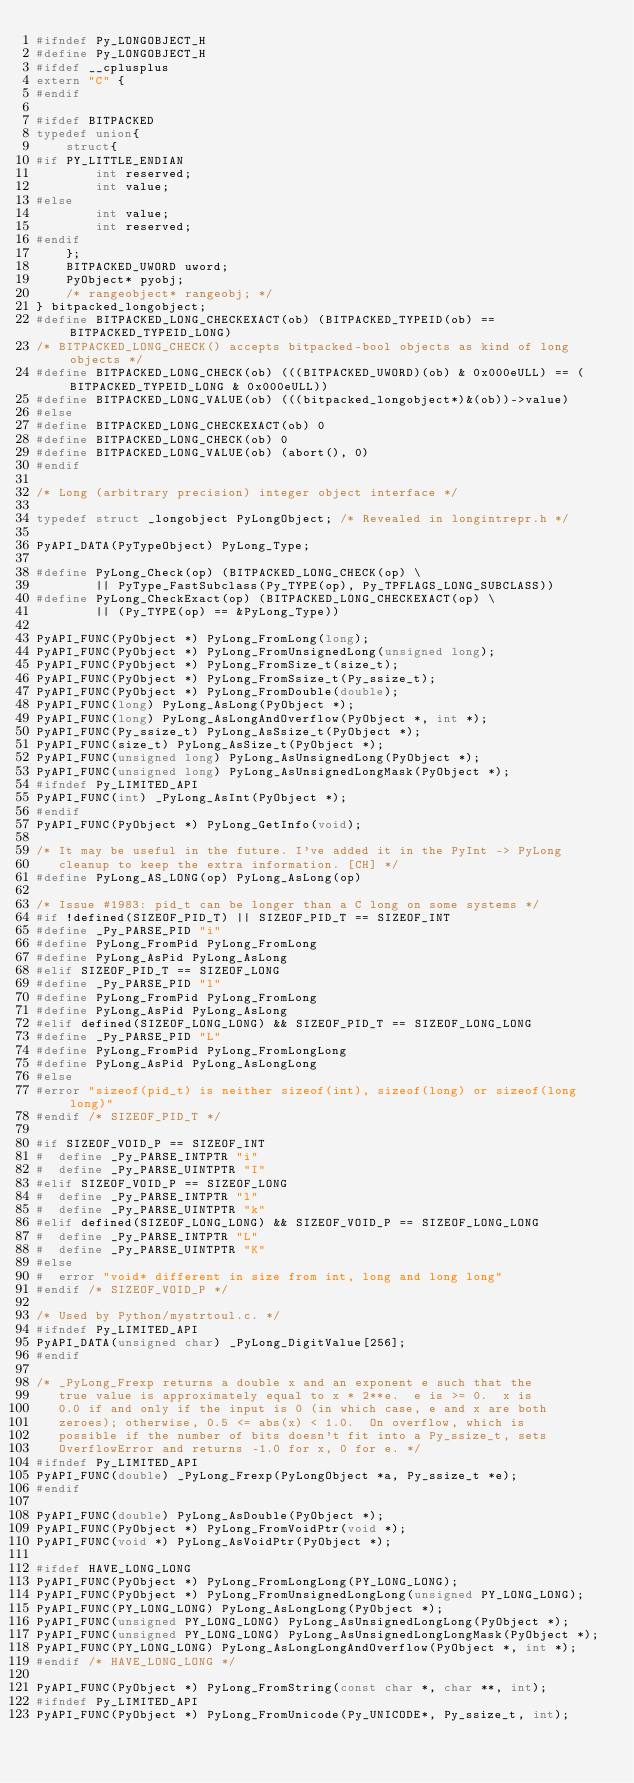<code> <loc_0><loc_0><loc_500><loc_500><_C_>#ifndef Py_LONGOBJECT_H
#define Py_LONGOBJECT_H
#ifdef __cplusplus
extern "C" {
#endif

#ifdef BITPACKED
typedef union{
    struct{
#if PY_LITTLE_ENDIAN
        int reserved;
        int value;
#else
        int value;
        int reserved;
#endif
    };
    BITPACKED_UWORD uword;
    PyObject* pyobj;
    /* rangeobject* rangeobj; */
} bitpacked_longobject;
#define BITPACKED_LONG_CHECKEXACT(ob) (BITPACKED_TYPEID(ob) == BITPACKED_TYPEID_LONG)
/* BITPACKED_LONG_CHECK() accepts bitpacked-bool objects as kind of long objects */
#define BITPACKED_LONG_CHECK(ob) (((BITPACKED_UWORD)(ob) & 0x000eULL) == (BITPACKED_TYPEID_LONG & 0x000eULL))
#define BITPACKED_LONG_VALUE(ob) (((bitpacked_longobject*)&(ob))->value)
#else
#define BITPACKED_LONG_CHECKEXACT(ob) 0
#define BITPACKED_LONG_CHECK(ob) 0
#define BITPACKED_LONG_VALUE(ob) (abort(), 0)
#endif

/* Long (arbitrary precision) integer object interface */

typedef struct _longobject PyLongObject; /* Revealed in longintrepr.h */

PyAPI_DATA(PyTypeObject) PyLong_Type;

#define PyLong_Check(op) (BITPACKED_LONG_CHECK(op) \
        || PyType_FastSubclass(Py_TYPE(op), Py_TPFLAGS_LONG_SUBCLASS))
#define PyLong_CheckExact(op) (BITPACKED_LONG_CHECKEXACT(op) \
        || (Py_TYPE(op) == &PyLong_Type))

PyAPI_FUNC(PyObject *) PyLong_FromLong(long);
PyAPI_FUNC(PyObject *) PyLong_FromUnsignedLong(unsigned long);
PyAPI_FUNC(PyObject *) PyLong_FromSize_t(size_t);
PyAPI_FUNC(PyObject *) PyLong_FromSsize_t(Py_ssize_t);
PyAPI_FUNC(PyObject *) PyLong_FromDouble(double);
PyAPI_FUNC(long) PyLong_AsLong(PyObject *);
PyAPI_FUNC(long) PyLong_AsLongAndOverflow(PyObject *, int *);
PyAPI_FUNC(Py_ssize_t) PyLong_AsSsize_t(PyObject *);
PyAPI_FUNC(size_t) PyLong_AsSize_t(PyObject *);
PyAPI_FUNC(unsigned long) PyLong_AsUnsignedLong(PyObject *);
PyAPI_FUNC(unsigned long) PyLong_AsUnsignedLongMask(PyObject *);
#ifndef Py_LIMITED_API
PyAPI_FUNC(int) _PyLong_AsInt(PyObject *);
#endif
PyAPI_FUNC(PyObject *) PyLong_GetInfo(void);

/* It may be useful in the future. I've added it in the PyInt -> PyLong
   cleanup to keep the extra information. [CH] */
#define PyLong_AS_LONG(op) PyLong_AsLong(op)

/* Issue #1983: pid_t can be longer than a C long on some systems */
#if !defined(SIZEOF_PID_T) || SIZEOF_PID_T == SIZEOF_INT
#define _Py_PARSE_PID "i"
#define PyLong_FromPid PyLong_FromLong
#define PyLong_AsPid PyLong_AsLong
#elif SIZEOF_PID_T == SIZEOF_LONG
#define _Py_PARSE_PID "l"
#define PyLong_FromPid PyLong_FromLong
#define PyLong_AsPid PyLong_AsLong
#elif defined(SIZEOF_LONG_LONG) && SIZEOF_PID_T == SIZEOF_LONG_LONG
#define _Py_PARSE_PID "L"
#define PyLong_FromPid PyLong_FromLongLong
#define PyLong_AsPid PyLong_AsLongLong
#else
#error "sizeof(pid_t) is neither sizeof(int), sizeof(long) or sizeof(long long)"
#endif /* SIZEOF_PID_T */

#if SIZEOF_VOID_P == SIZEOF_INT
#  define _Py_PARSE_INTPTR "i"
#  define _Py_PARSE_UINTPTR "I"
#elif SIZEOF_VOID_P == SIZEOF_LONG
#  define _Py_PARSE_INTPTR "l"
#  define _Py_PARSE_UINTPTR "k"
#elif defined(SIZEOF_LONG_LONG) && SIZEOF_VOID_P == SIZEOF_LONG_LONG
#  define _Py_PARSE_INTPTR "L"
#  define _Py_PARSE_UINTPTR "K"
#else
#  error "void* different in size from int, long and long long"
#endif /* SIZEOF_VOID_P */

/* Used by Python/mystrtoul.c. */
#ifndef Py_LIMITED_API
PyAPI_DATA(unsigned char) _PyLong_DigitValue[256];
#endif

/* _PyLong_Frexp returns a double x and an exponent e such that the
   true value is approximately equal to x * 2**e.  e is >= 0.  x is
   0.0 if and only if the input is 0 (in which case, e and x are both
   zeroes); otherwise, 0.5 <= abs(x) < 1.0.  On overflow, which is
   possible if the number of bits doesn't fit into a Py_ssize_t, sets
   OverflowError and returns -1.0 for x, 0 for e. */
#ifndef Py_LIMITED_API
PyAPI_FUNC(double) _PyLong_Frexp(PyLongObject *a, Py_ssize_t *e);
#endif

PyAPI_FUNC(double) PyLong_AsDouble(PyObject *);
PyAPI_FUNC(PyObject *) PyLong_FromVoidPtr(void *);
PyAPI_FUNC(void *) PyLong_AsVoidPtr(PyObject *);

#ifdef HAVE_LONG_LONG
PyAPI_FUNC(PyObject *) PyLong_FromLongLong(PY_LONG_LONG);
PyAPI_FUNC(PyObject *) PyLong_FromUnsignedLongLong(unsigned PY_LONG_LONG);
PyAPI_FUNC(PY_LONG_LONG) PyLong_AsLongLong(PyObject *);
PyAPI_FUNC(unsigned PY_LONG_LONG) PyLong_AsUnsignedLongLong(PyObject *);
PyAPI_FUNC(unsigned PY_LONG_LONG) PyLong_AsUnsignedLongLongMask(PyObject *);
PyAPI_FUNC(PY_LONG_LONG) PyLong_AsLongLongAndOverflow(PyObject *, int *);
#endif /* HAVE_LONG_LONG */

PyAPI_FUNC(PyObject *) PyLong_FromString(const char *, char **, int);
#ifndef Py_LIMITED_API
PyAPI_FUNC(PyObject *) PyLong_FromUnicode(Py_UNICODE*, Py_ssize_t, int);</code> 